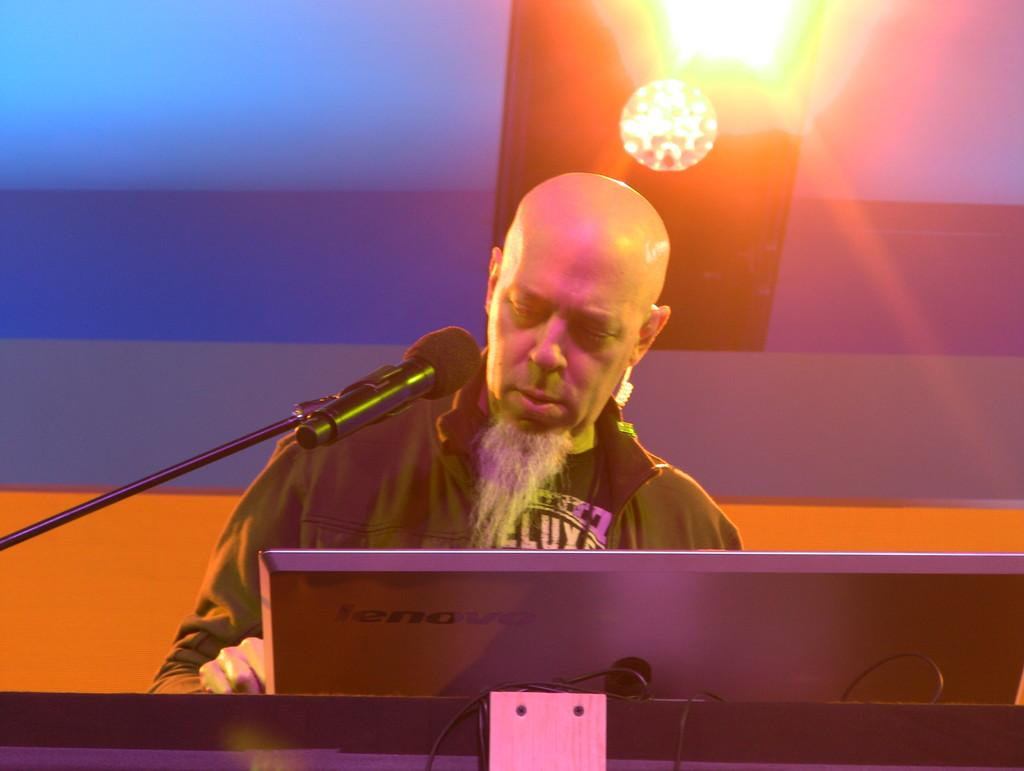Who is the main subject in the image? There is a man in the middle of the image. What is the man interacting with in the image? The man is interacting with a screen and a mic fixed to a stand in front of him. What can be seen behind the man in the image? There is a wall in the background of the image. What is the price of the arm that the man is using in the image? There is no arm being used in the image; the man is using a mic and interacting with a screen. 